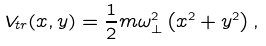Convert formula to latex. <formula><loc_0><loc_0><loc_500><loc_500>V _ { t r } ( x , y ) = \frac { 1 } { 2 } m \omega _ { \perp } ^ { 2 } \left ( x ^ { 2 } + y ^ { 2 } \right ) ,</formula> 